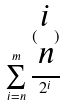<formula> <loc_0><loc_0><loc_500><loc_500>\sum _ { i = n } ^ { m } \frac { ( \begin{matrix} i \\ n \end{matrix} ) } { 2 ^ { i } }</formula> 